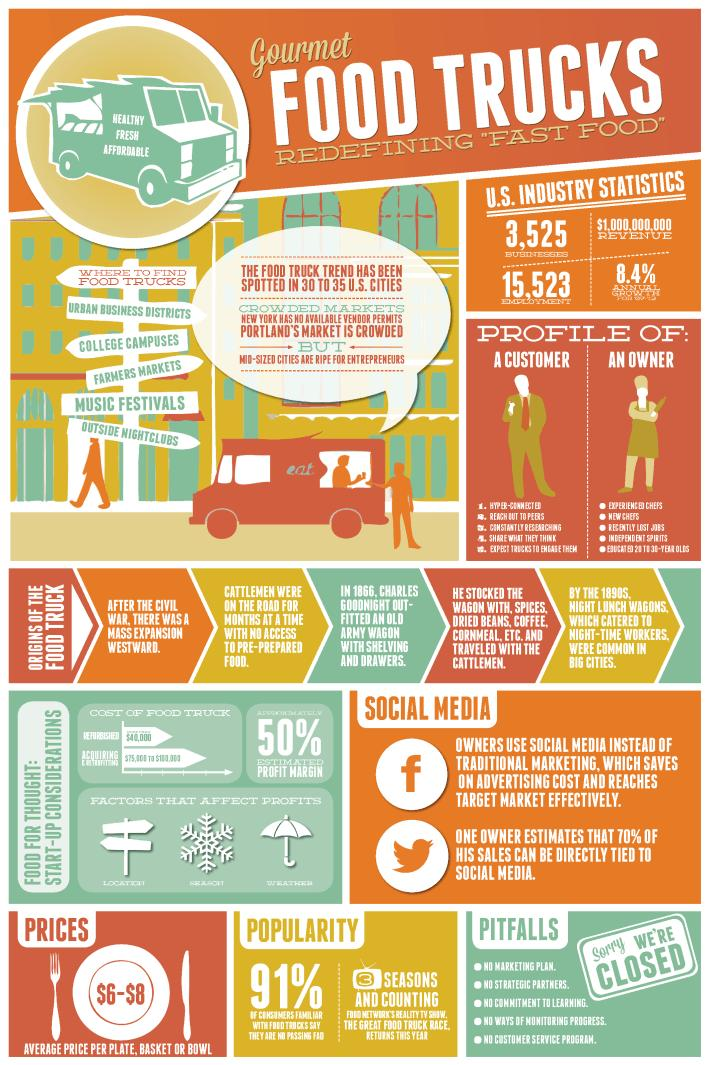Mention a couple of crucial points in this snapshot. The profit of a food truck business can be affected by a variety of factors, including the cost of food and supplies, the price of labor, and the revenue generated by sales. These factors can have a significant impact on the overall financial performance of a food truck business and it is important for business owners to understand and manage them effectively. As of the latest data available, there are a total of 15,523 Food Truck jobs in the United States. Urban business districts are the first and foremost place to find food trucks, providing individuals with a convenient and tasty dining option. According to a recent survey, only 9% of people in America are not familiar with food trucks. The infographic lists food trucks in various places, and the fourth place mentioned is Music Festivals. 